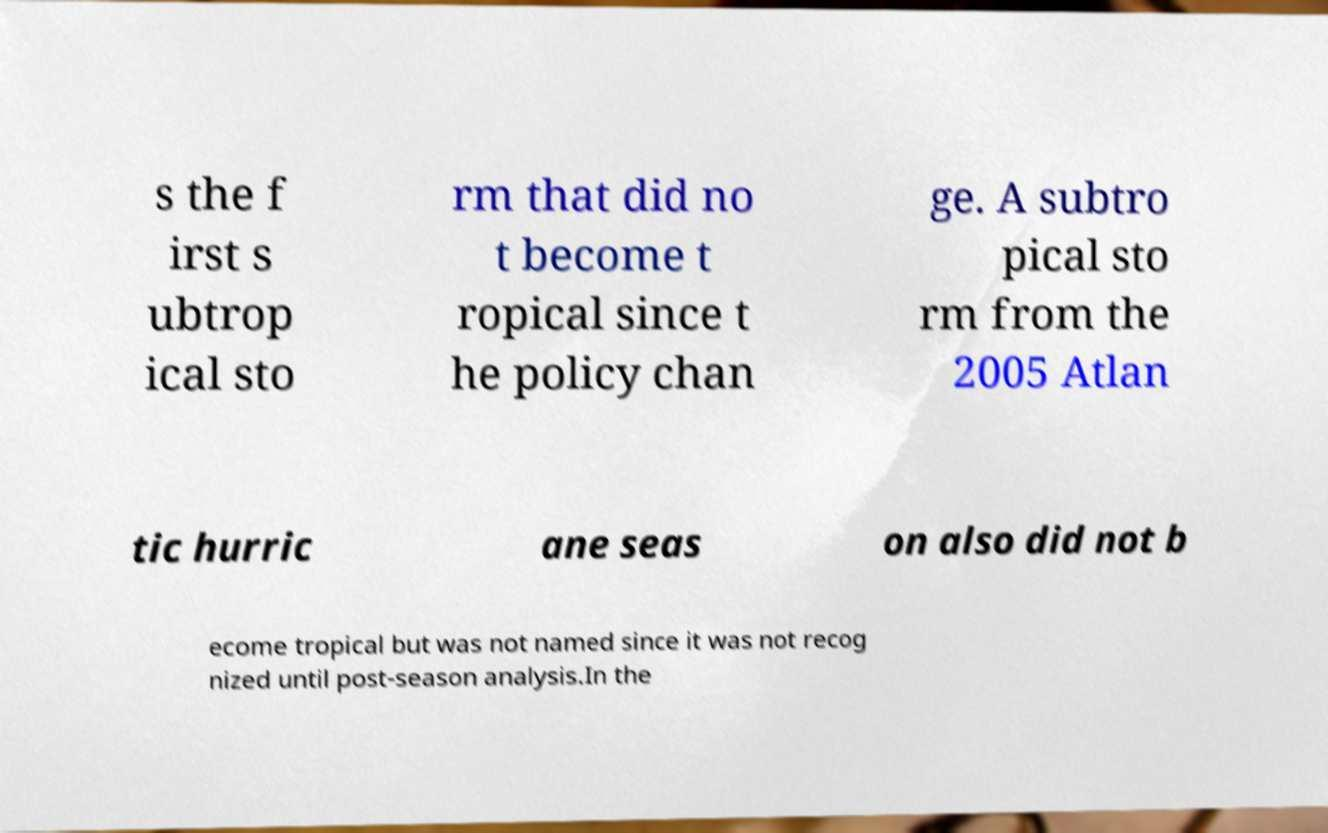There's text embedded in this image that I need extracted. Can you transcribe it verbatim? s the f irst s ubtrop ical sto rm that did no t become t ropical since t he policy chan ge. A subtro pical sto rm from the 2005 Atlan tic hurric ane seas on also did not b ecome tropical but was not named since it was not recog nized until post-season analysis.In the 